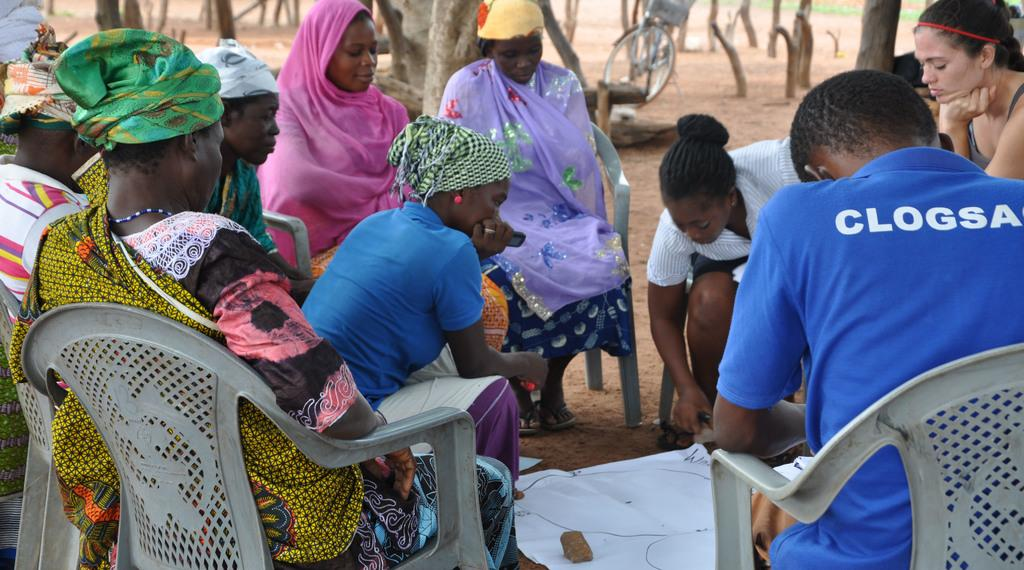How many people are in the image? There is a group of people in the image. What are the people doing in the image? The people are sitting on chairs. What is in the middle of the group of people? There is a chart paper in the middle of the group. What can be seen in the background of the image? Trees and a bicycle are visible in the background of the image. What type of skate is being used by the people in the image? There is no skate present in the image; the people are sitting on chairs. Can you tell me how many toads are sitting on the chart paper in the image? There are no toads present in the image; only a group of people and a chart paper are visible. 